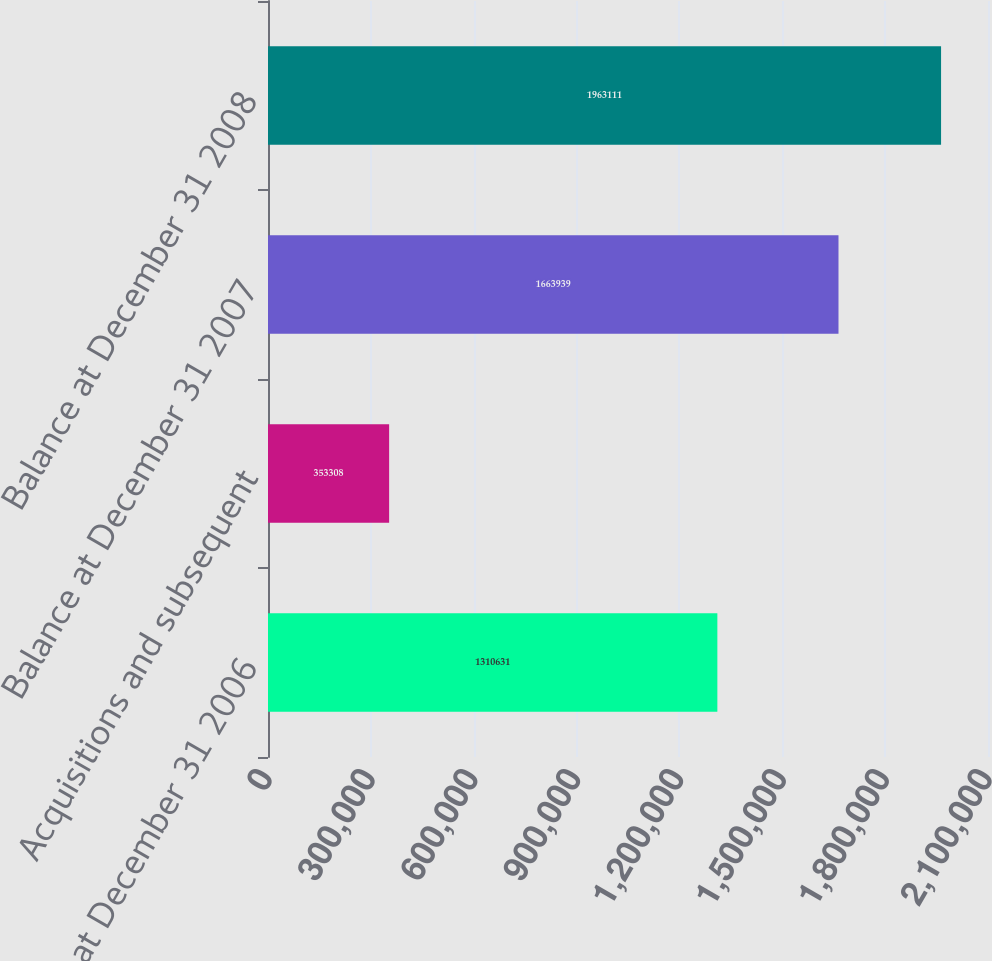Convert chart. <chart><loc_0><loc_0><loc_500><loc_500><bar_chart><fcel>Balance at December 31 2006<fcel>Acquisitions and subsequent<fcel>Balance at December 31 2007<fcel>Balance at December 31 2008<nl><fcel>1.31063e+06<fcel>353308<fcel>1.66394e+06<fcel>1.96311e+06<nl></chart> 